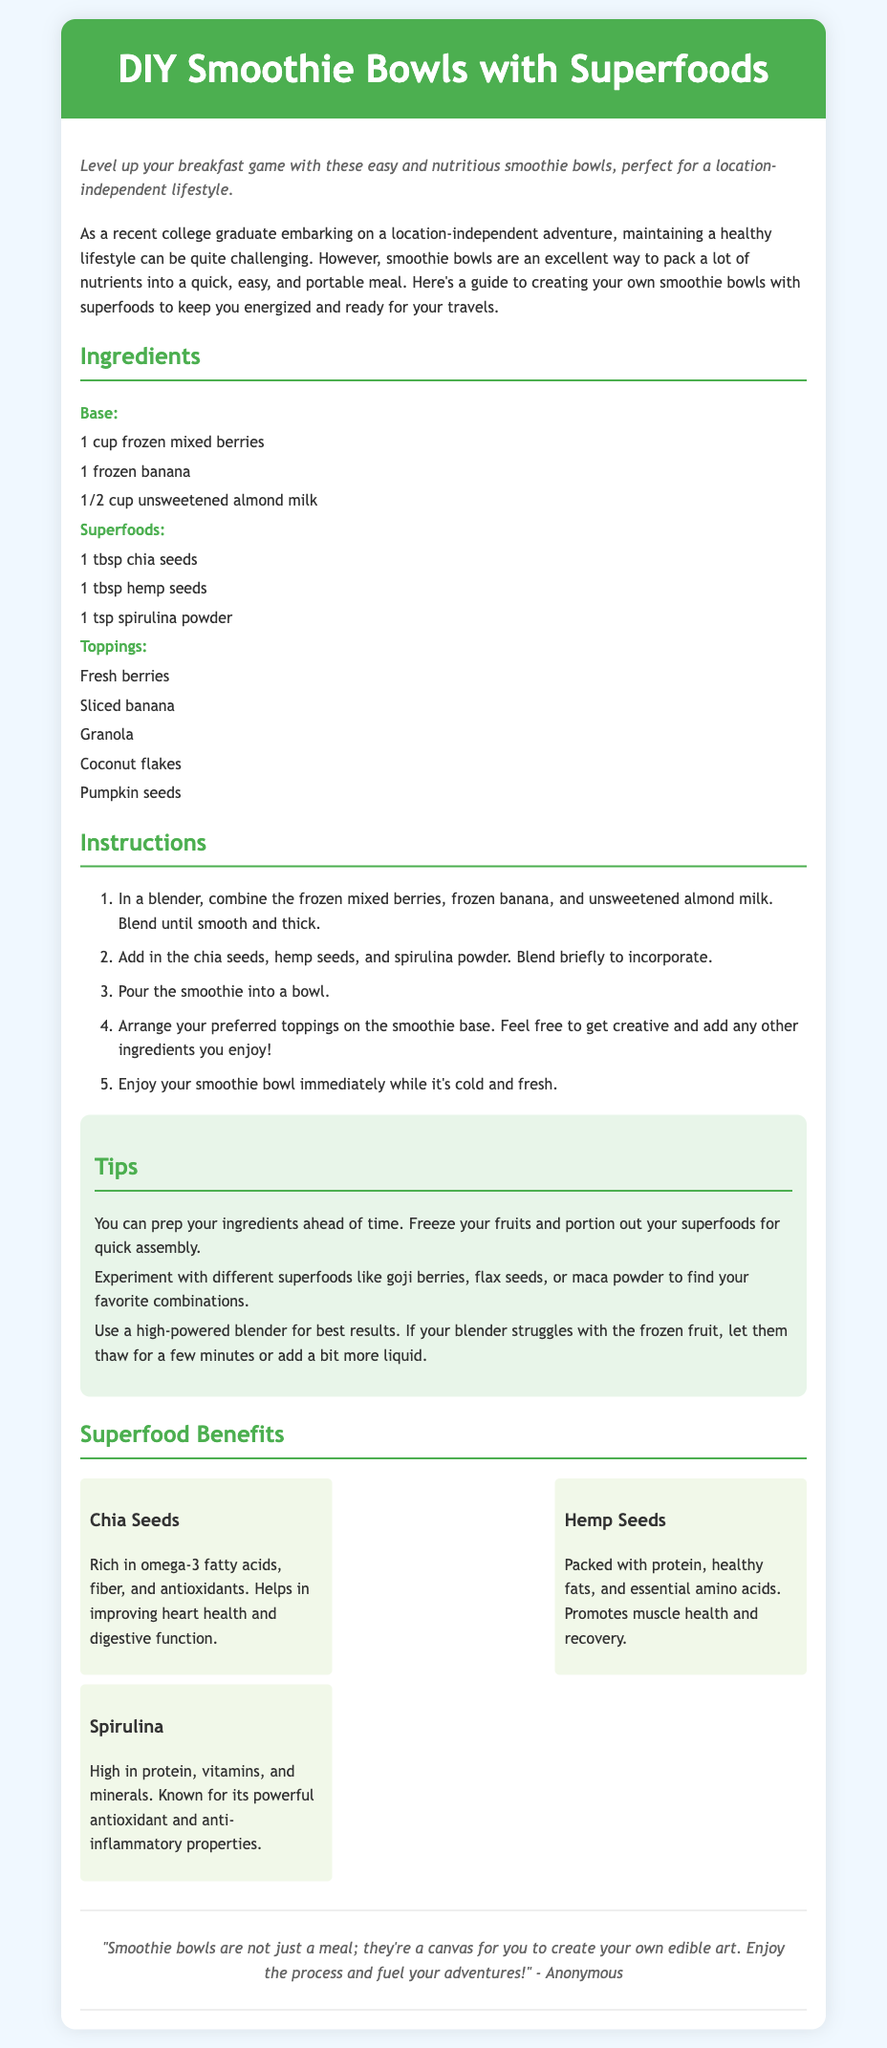what is the main theme of the document? The main theme is about creating smoothie bowls that are nutritious and suitable for a location-independent lifestyle.
Answer: smoothie bowls how many ingredients are listed for the base? The document specifies three ingredients under the base category.
Answer: 3 what are the toppings suggested for the smoothie bowls? The toppings include fresh berries, sliced banana, granola, coconut flakes, and pumpkin seeds.
Answer: fresh berries, sliced banana, granola, coconut flakes, pumpkin seeds name one benefit of chia seeds mentioned in the document. Chia seeds are described as being rich in omega-3 fatty acids, fiber, and antioxidants.
Answer: heart health how many steps are in the instructions section? The instructions section consists of five steps to make the smoothie bowl.
Answer: 5 which superfood is noted for its protein content? The superfood that is high in protein is hemp seeds.
Answer: hemp seeds what is the overall recommended action after preparing the smoothie bowl? The document recommends enjoying the smoothie bowl immediately while it's cold and fresh.
Answer: enjoy immediately list one tip provided for preparing the smoothie bowls. It is suggested to prep ingredients ahead of time by freezing fruits and portioning out superfoods.
Answer: prep ingredients ahead of time 